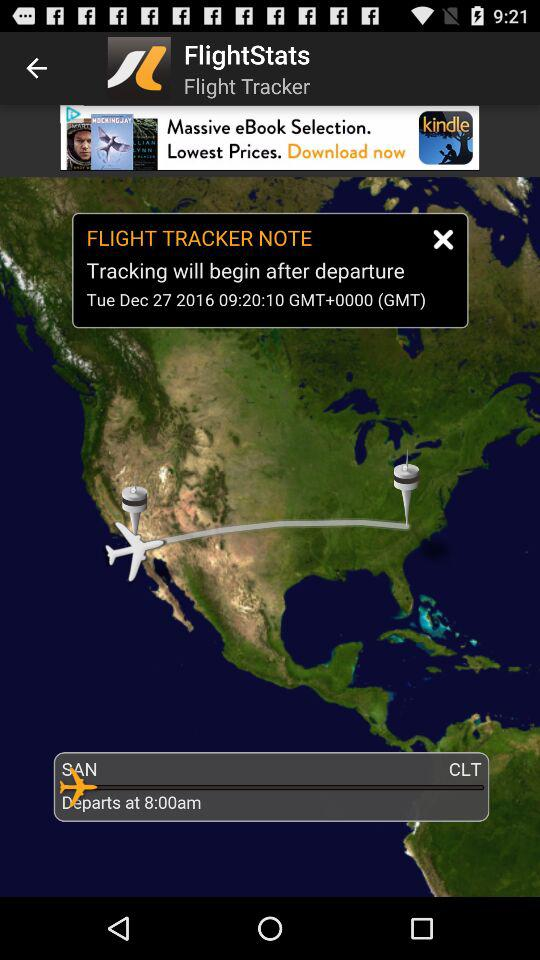When will the tracking begin? The tracking will begin after departure. 